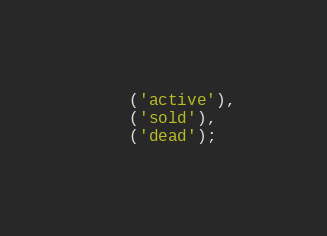Convert code to text. <code><loc_0><loc_0><loc_500><loc_500><_SQL_>    ('active'),
    ('sold'),
    ('dead');</code> 